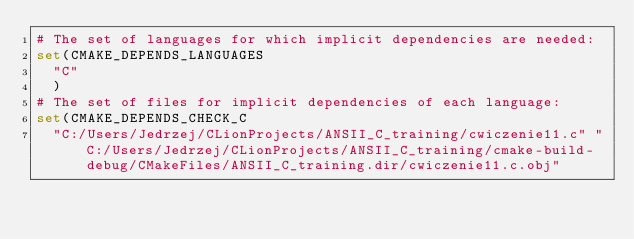Convert code to text. <code><loc_0><loc_0><loc_500><loc_500><_CMake_># The set of languages for which implicit dependencies are needed:
set(CMAKE_DEPENDS_LANGUAGES
  "C"
  )
# The set of files for implicit dependencies of each language:
set(CMAKE_DEPENDS_CHECK_C
  "C:/Users/Jedrzej/CLionProjects/ANSII_C_training/cwiczenie11.c" "C:/Users/Jedrzej/CLionProjects/ANSII_C_training/cmake-build-debug/CMakeFiles/ANSII_C_training.dir/cwiczenie11.c.obj"</code> 